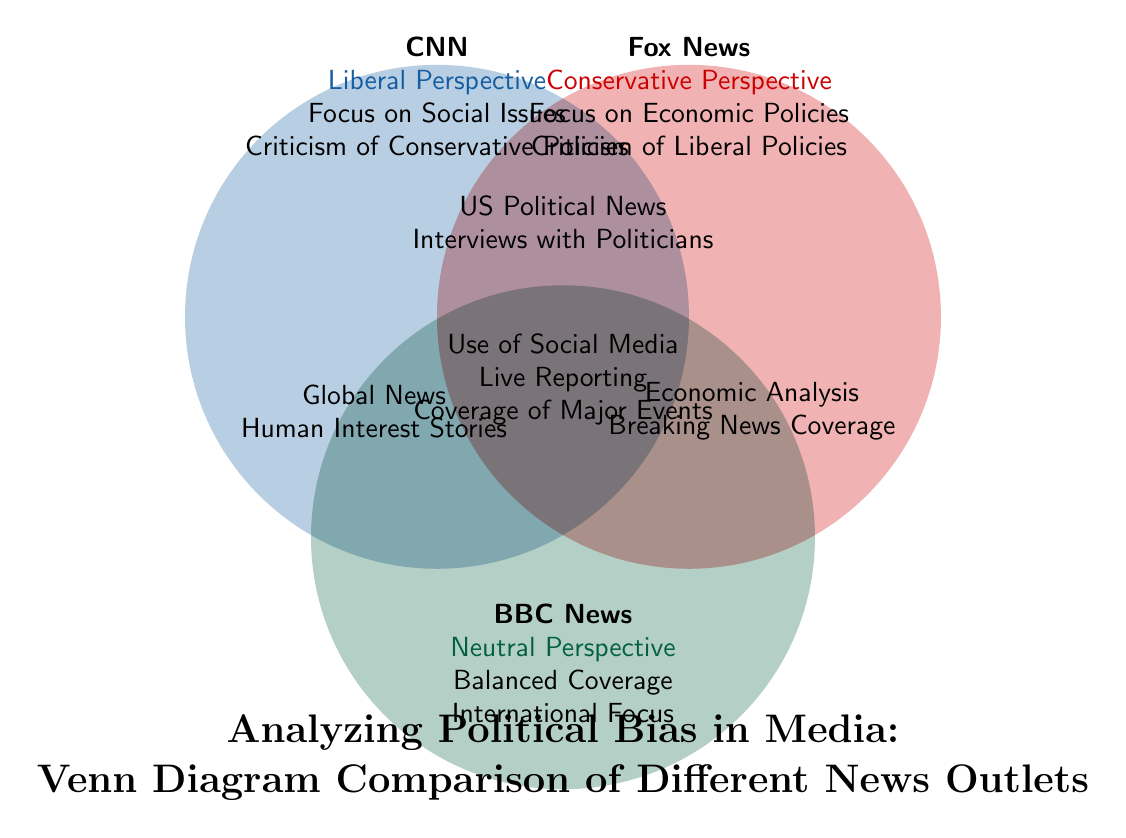What is the primary political perspective associated with CNN? The diagram indicates that CNN is associated with a "Liberal Perspective" as stated in the labeled area for CNN.
Answer: Liberal Perspective What type of coverage does BBC News provide? According to the information under BBC News, it states "Balanced Coverage" as part of its description, indicating its approach to news reporting.
Answer: Balanced Coverage Which outlet is criticized for its coverage of Liberal Policies? The diagram notes that "Fox News" is described as having a focus on "Criticism of Liberal Policies," which identifies it as the outlet being critiqued.
Answer: Fox News What common topic is covered by all three news outlets? The area in the center of the Venn diagram indicates commonalities with "US Political News," showing that all three share this coverage topic.
Answer: US Political News How many news outlets are represented in the diagram? The diagram clearly illustrates three circles representing three news outlets: CNN, Fox News, and BBC News, which counts to three.
Answer: 3 Which two news outlets focus on social issues? The information provided shows that CNN and BBC News both include social issues in their descriptions, indicating they focus on this topic.
Answer: CNN and BBC News What unique coverage topic is specific to Fox News? The diagram states that Fox News has a focus on "Economic Policies," which distinguishes it from the other outlets regarding this topic.
Answer: Economic Policies Which outlet is characterized as having a neutral perspective? The labeling in the diagram specifically assigns "Neutral Perspective" to BBC News, marking it as distinct from the other two outlets.
Answer: BBC News What type of reporting does CNN engage in according to the diagram? CNN is specified as engaging in "Live Reporting," indicating the type of coverage they prioritize.
Answer: Live Reporting 